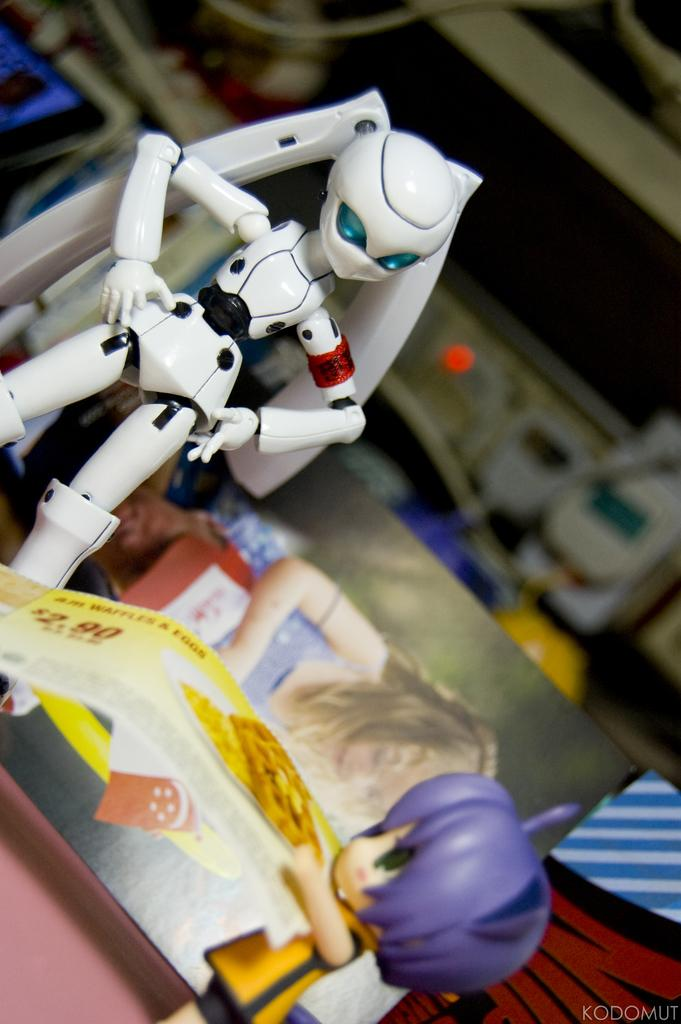How many toys can be seen in the image? There are two toys in the image. What can be seen in the background of the image? There are banners and other objects visible in the background of the image. Can you describe the watermark in the image? There is a watermark in the right bottom of the image. Is there a dog lifting a kettle in the image? No, there is no dog or kettle present in the image. 